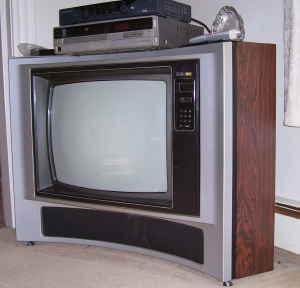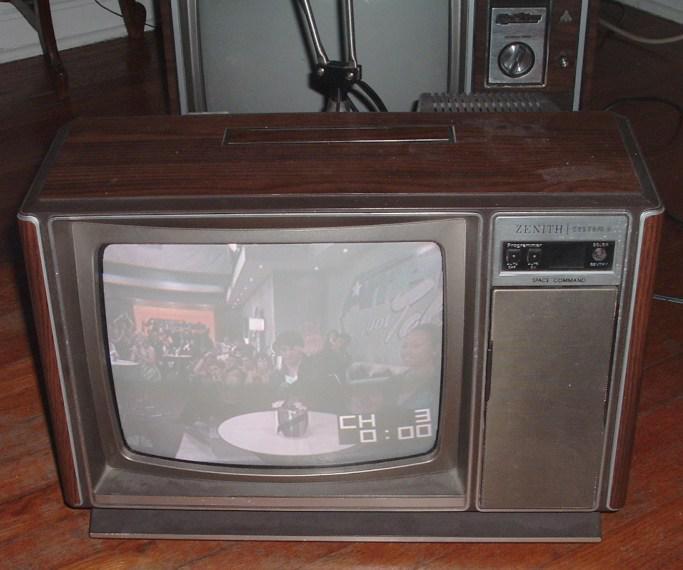The first image is the image on the left, the second image is the image on the right. Assess this claim about the two images: "One of the televsions is on.". Correct or not? Answer yes or no. Yes. 